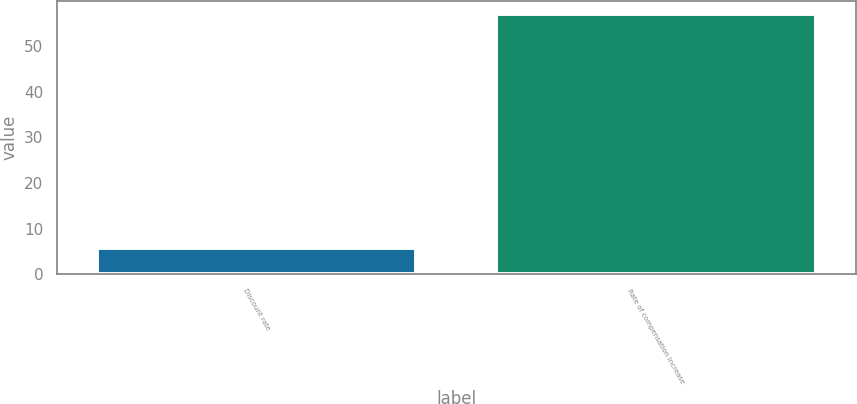Convert chart. <chart><loc_0><loc_0><loc_500><loc_500><bar_chart><fcel>Discount rate<fcel>Rate of compensation increase<nl><fcel>5.75<fcel>57<nl></chart> 